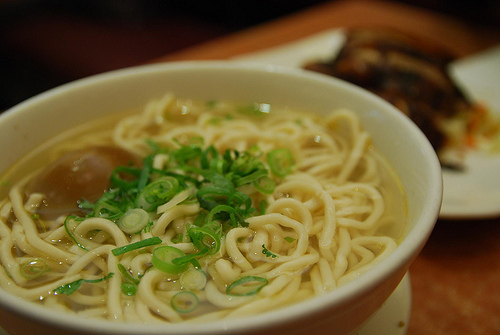<image>
Is the noodles under the plate? No. The noodles is not positioned under the plate. The vertical relationship between these objects is different. Is there a maggie in the bowl? Yes. The maggie is contained within or inside the bowl, showing a containment relationship. 